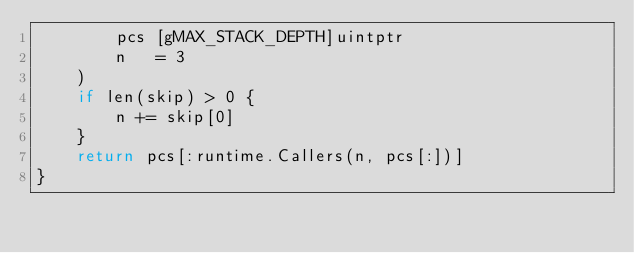Convert code to text. <code><loc_0><loc_0><loc_500><loc_500><_Go_>		pcs [gMAX_STACK_DEPTH]uintptr
		n   = 3
	)
	if len(skip) > 0 {
		n += skip[0]
	}
	return pcs[:runtime.Callers(n, pcs[:])]
}
</code> 